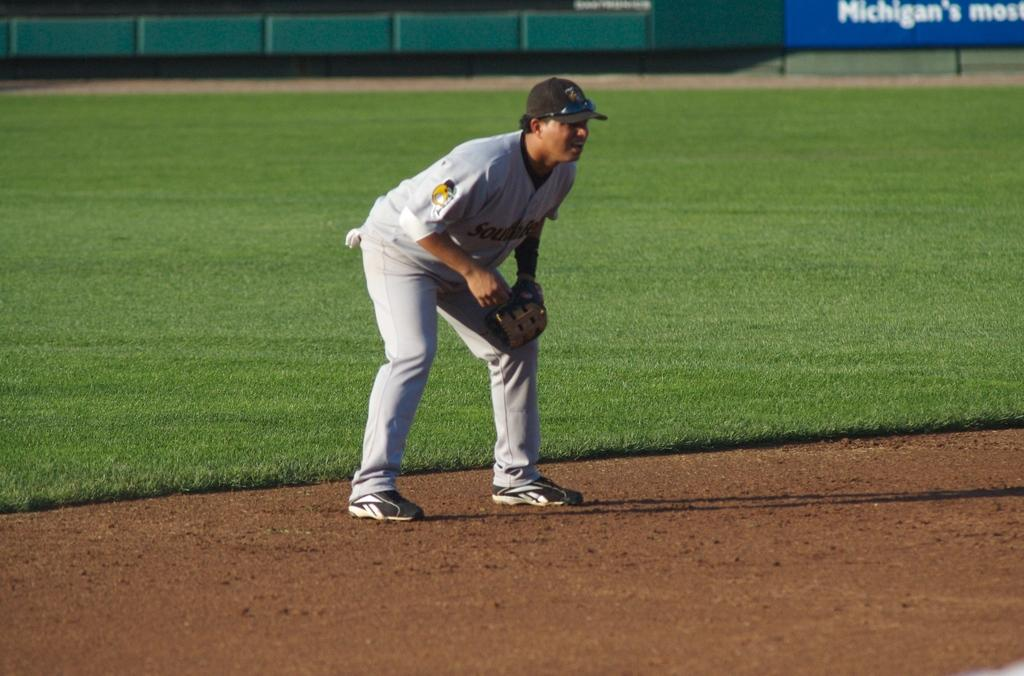<image>
Relay a brief, clear account of the picture shown. The state name Michigan can be seen on a baseball diamond. 